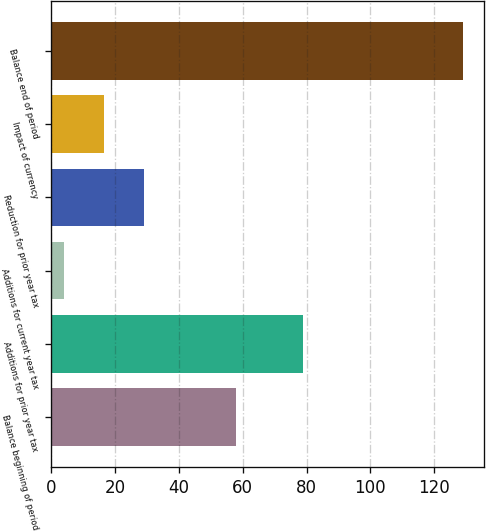<chart> <loc_0><loc_0><loc_500><loc_500><bar_chart><fcel>Balance beginning of period<fcel>Additions for prior year tax<fcel>Additions for current year tax<fcel>Reduction for prior year tax<fcel>Impact of currency<fcel>Balance end of period<nl><fcel>58<fcel>79<fcel>4<fcel>29<fcel>16.5<fcel>129<nl></chart> 